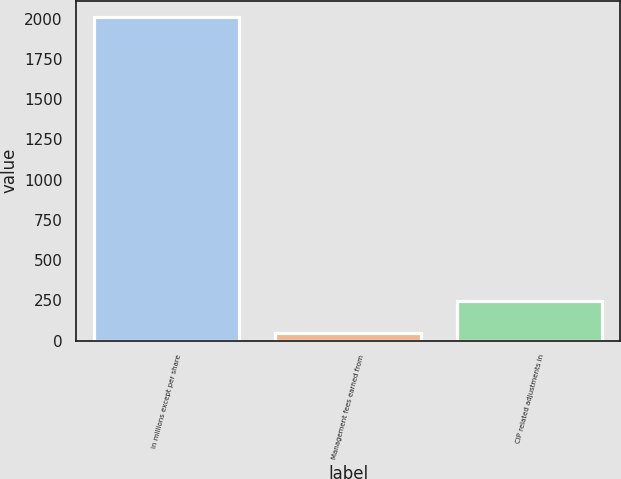<chart> <loc_0><loc_0><loc_500><loc_500><bar_chart><fcel>in millions except per share<fcel>Management fees earned from<fcel>CIP related adjustments in<nl><fcel>2011<fcel>46.8<fcel>243.22<nl></chart> 